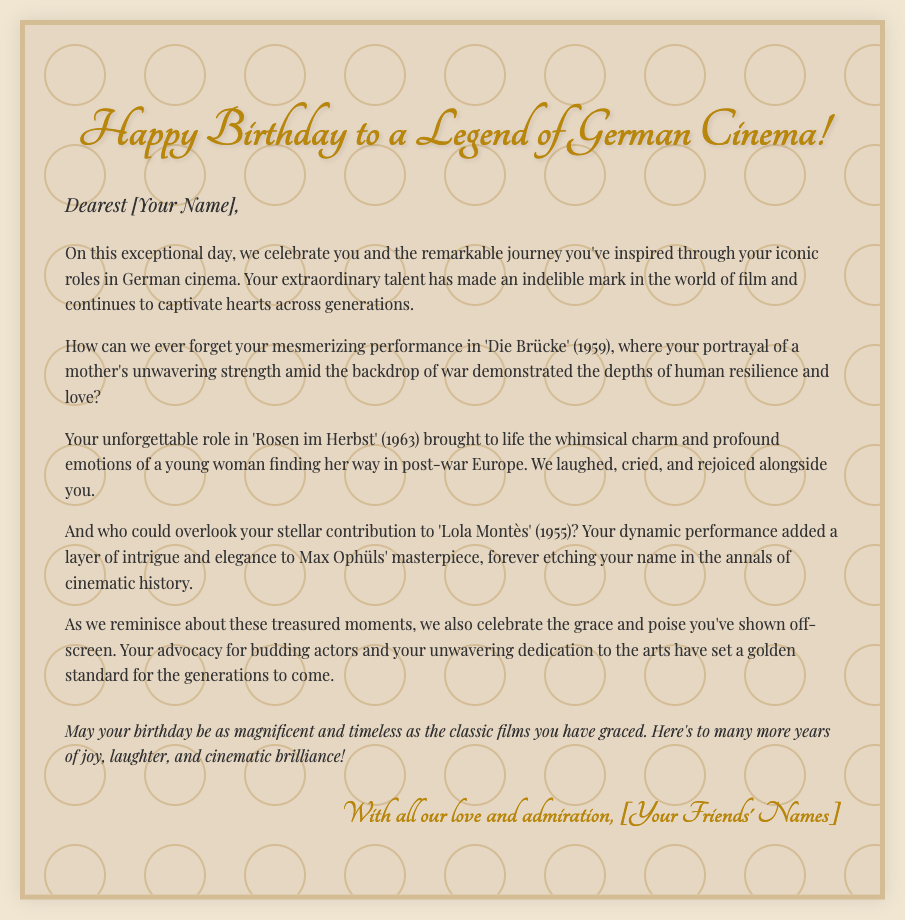What is the title of the card? The title of the card is presented in the prominent header of the document, which states "Happy Birthday to a Legend of German Cinema!"
Answer: Happy Birthday to a Legend of German Cinema! Who is the card addressed to? The greeting in the card begins with "Dearest [Your Name]," indicating it is personalized for the recipient.
Answer: [Your Name] In what year was 'Die Brücke' released? The document mentions 'Die Brücke' along with its release year in parentheses, which is 1959.
Answer: 1959 What is the theme of the birthday message? The overall theme centers around celebrating the recipient's impactful journey and contributions to German cinema.
Answer: Celebrating a legendary journey in German cinema What emotion does the message convey regarding the recipient's performances? The document describes the recipient's performances as mesmerizing and unforgettable, highlighting their talent and impact on audiences.
Answer: Mesmerizing and unforgettable What is mentioned about the recipient's contribution to arts? The card states that the recipient's advocacy for budding actors has set a golden standard, showcasing their commitment beyond acting.
Answer: Advocacy for budding actors How is the concluding wish in the card phrased? The closing message expresses a wish for the recipient's birthday to be "as magnificent and timeless as the classic films you have graced."
Answer: As magnificent and timeless as the classic films you have graced What is the purpose of this document? The main purpose of this document is to convey heartfelt birthday wishes and celebrate the recipient's legacy in cinema.
Answer: To convey heartfelt birthday wishes 